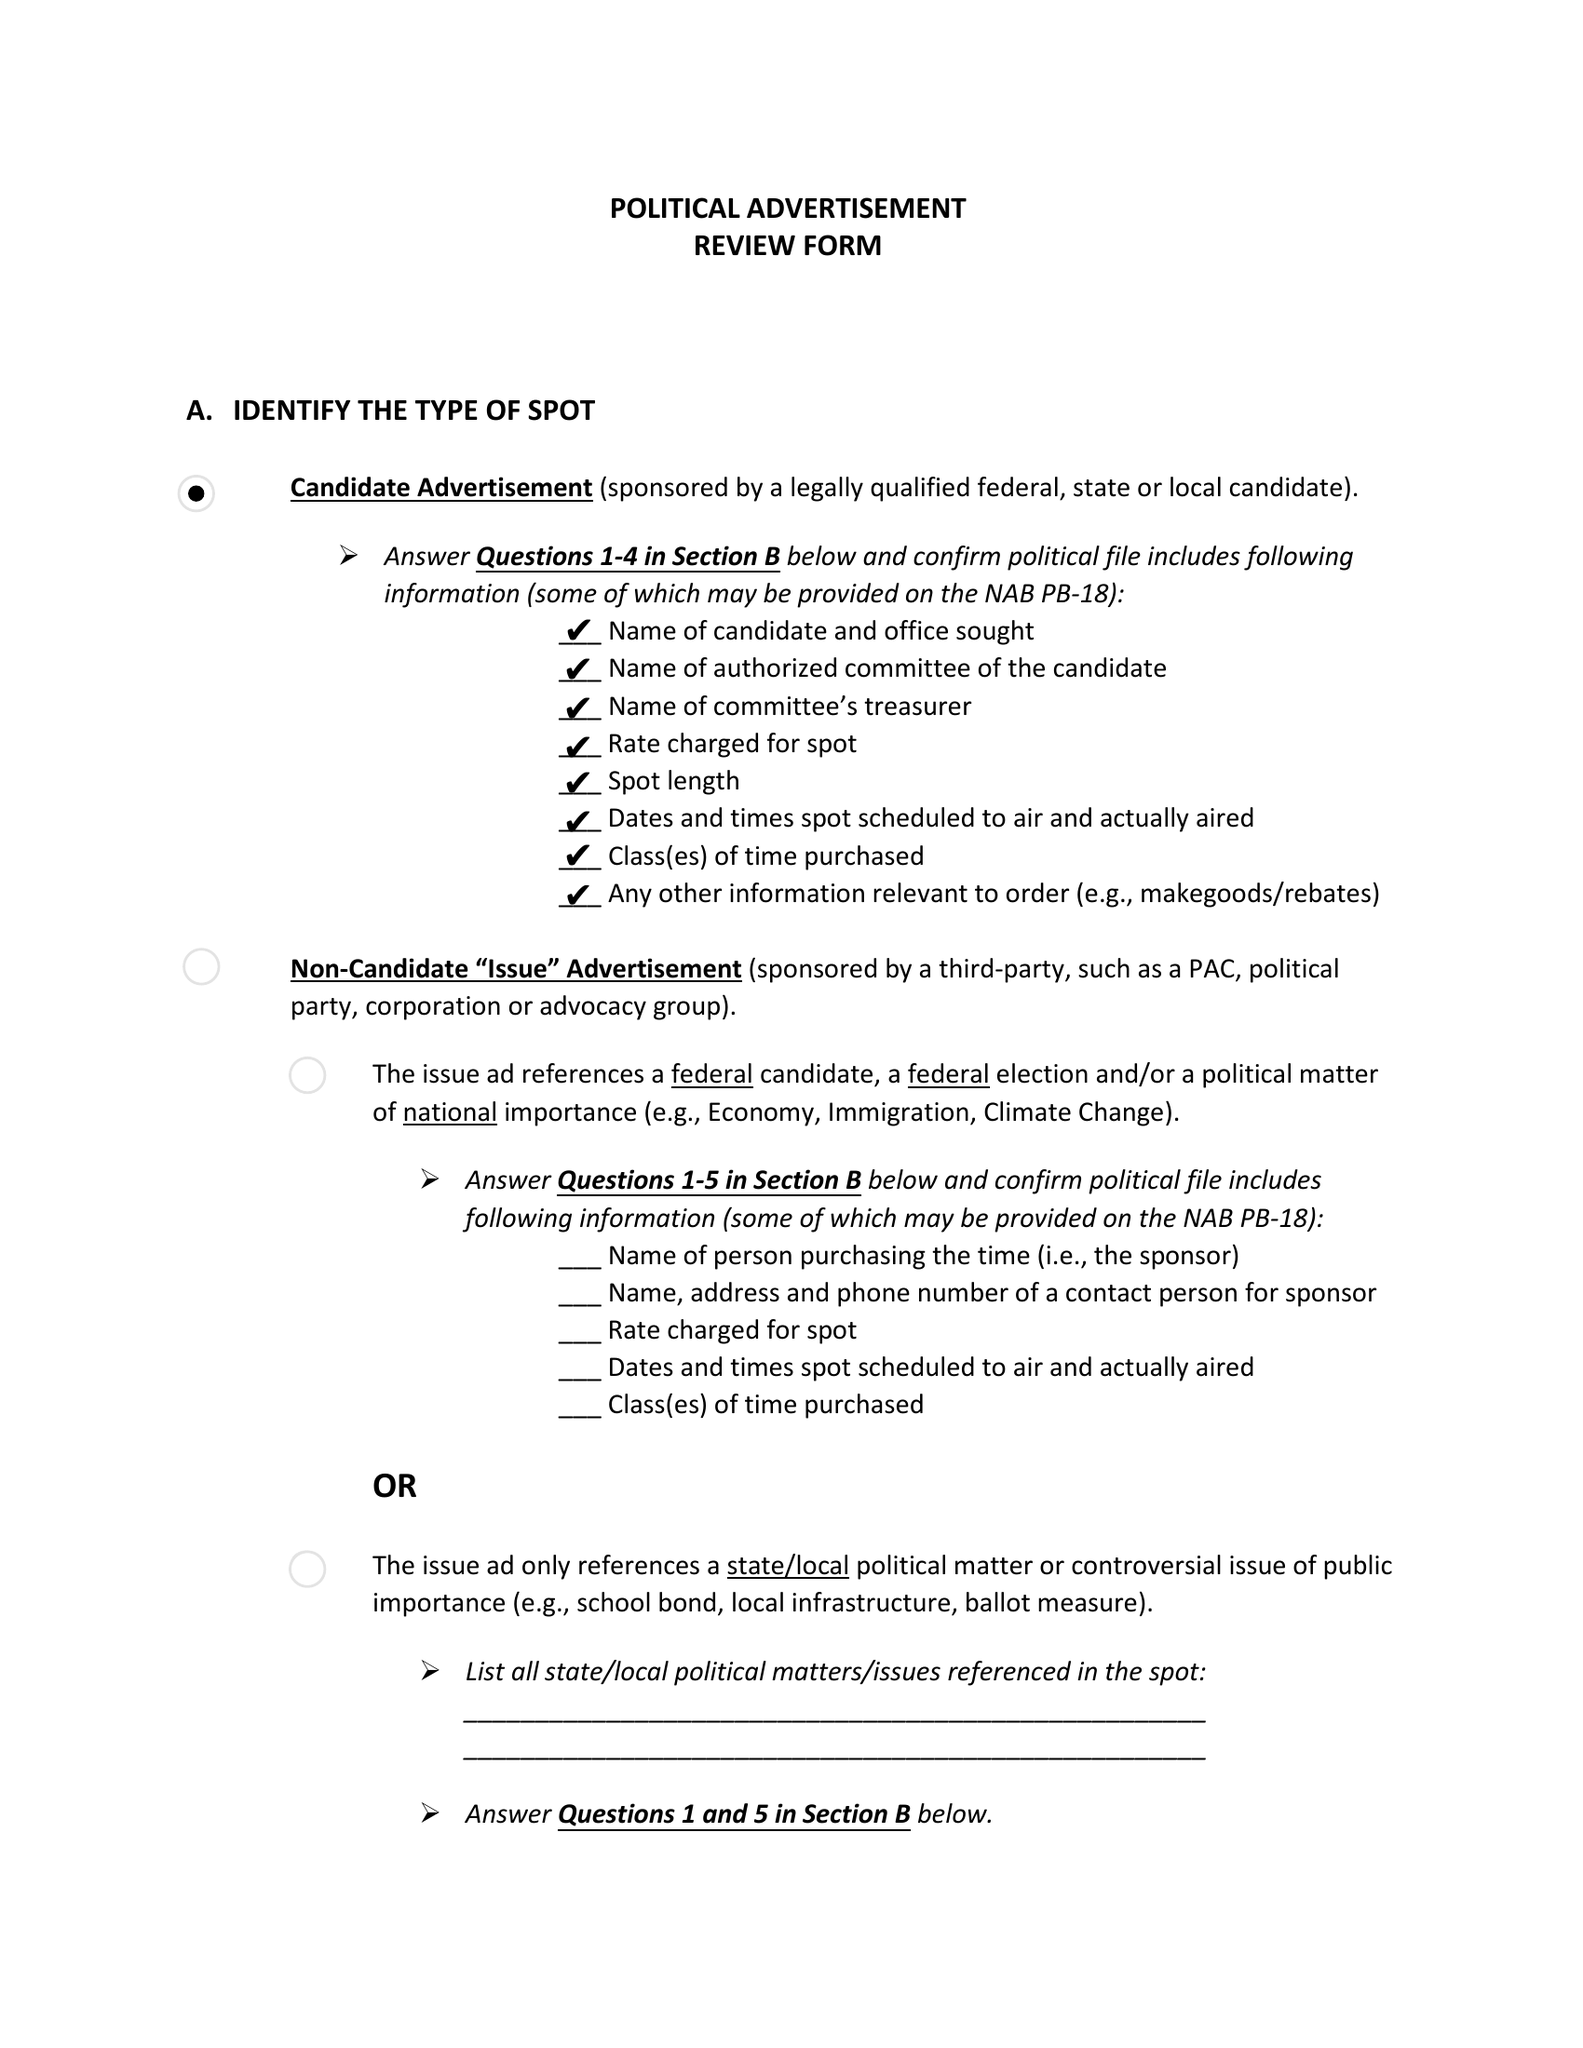What is the value for the flight_to?
Answer the question using a single word or phrase. None 